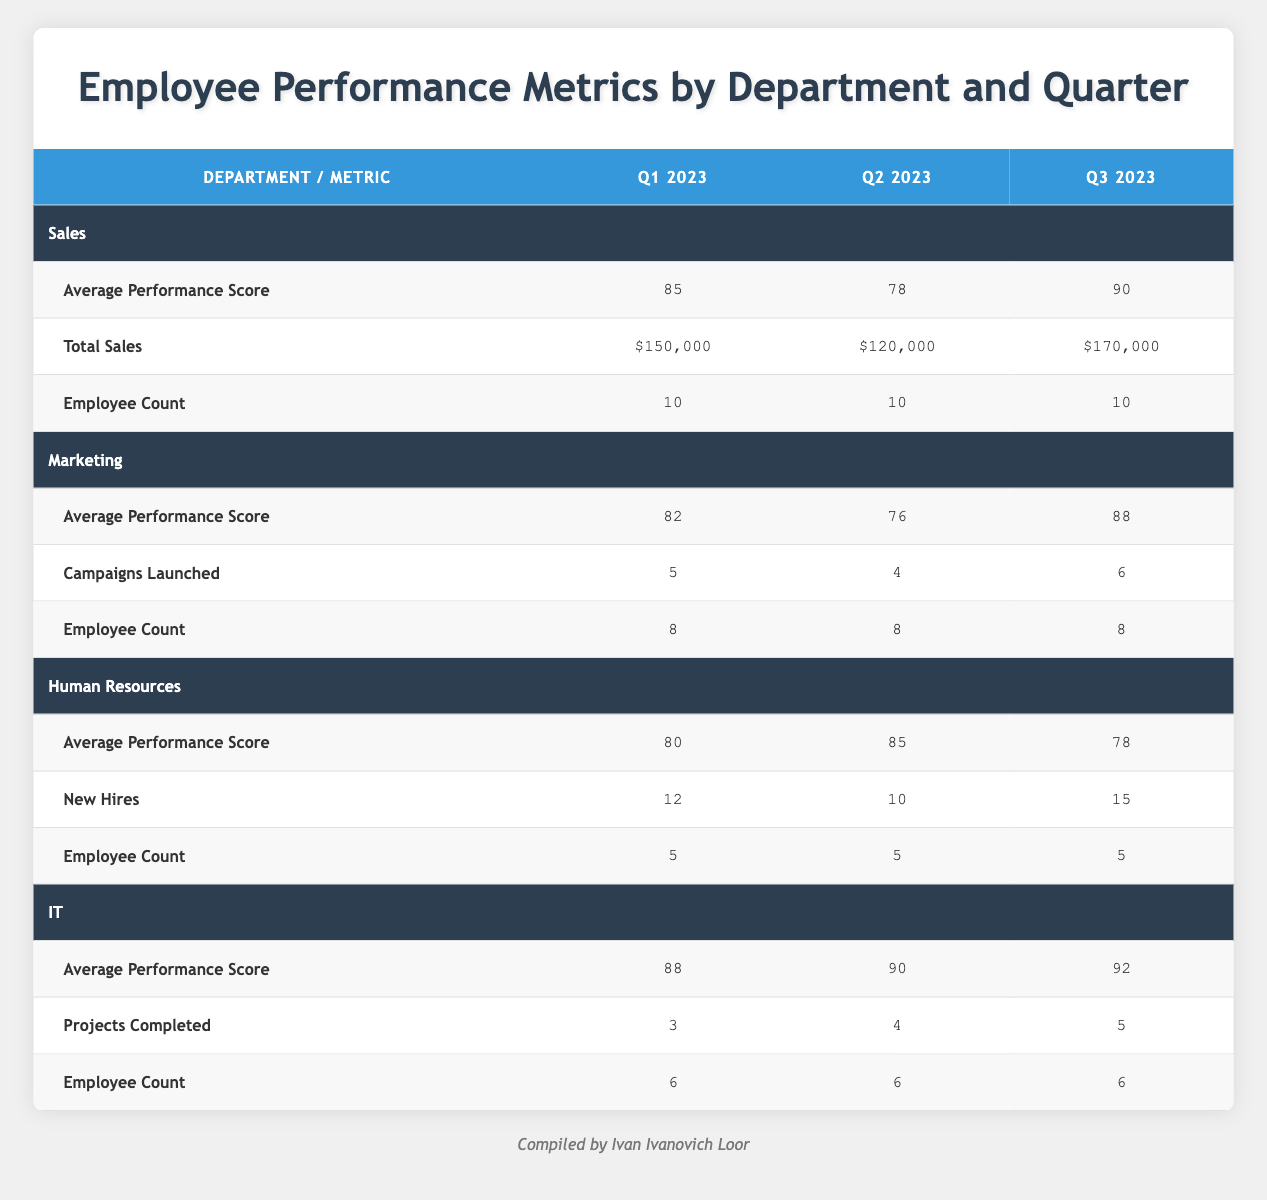What was the average performance score for the Sales department in Q2 2023? The table shows that the average performance score for the Sales department in Q2 2023 is listed directly as 78.
Answer: 78 How many total sales were made by the Marketing department in Q3 2023? The table does not provide a total sales figure for the Marketing department; instead, it provides information on campaigns launched. Therefore, I cannot answer this question based on the table's data.
Answer: Not available Did the IT department improve its average performance score from Q1 to Q2 in 2023? To answer this, I look at the average performance score for IT in both Q1 (88) and Q2 (90) and see that it increased from Q1 to Q2.
Answer: Yes What is the total number of new hires by the Human Resources department across all quarters? The table lists new hires as 12 in Q1, 10 in Q2, and 15 in Q3. Adding these together gives 12 + 10 + 15 = 37 new hires.
Answer: 37 In which quarter did the Marketing department launch the highest number of campaigns? By examining the campaigns launched: Q1 has 5, Q2 has 4, and Q3 has 6. Since 6 is the highest value, it was in Q3.
Answer: Q3 2023 What is the trend of average performance scores for Sales from Q1 to Q3 2023? The average performance scores for Sales are 85 in Q1, 78 in Q2, and 90 in Q3. This shows a decline from Q1 to Q2 followed by an increase from Q2 to Q3.
Answer: Decline then increase How many employees are in the Human Resources department? The employee count for the Human Resources department is given as 5 consistently across all quarters.
Answer: 5 Which department had the highest average performance score in Q3 2023? The average performance scores in Q3 for each department are: Sales (90), Marketing (88), Human Resources (78), and IT (92). The highest score is from IT at 92.
Answer: IT How many projects were completed by the IT department in total across all quarters? The table shows projects completed as 3 in Q1, 4 in Q2, and 5 in Q3. Adding these (3 + 4 + 5) results in 12 projects completed in total.
Answer: 12 